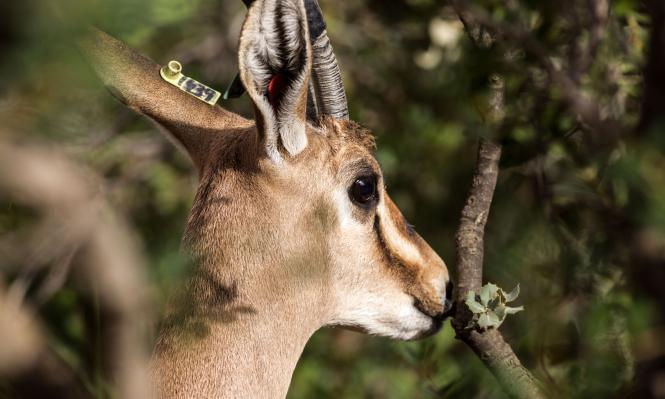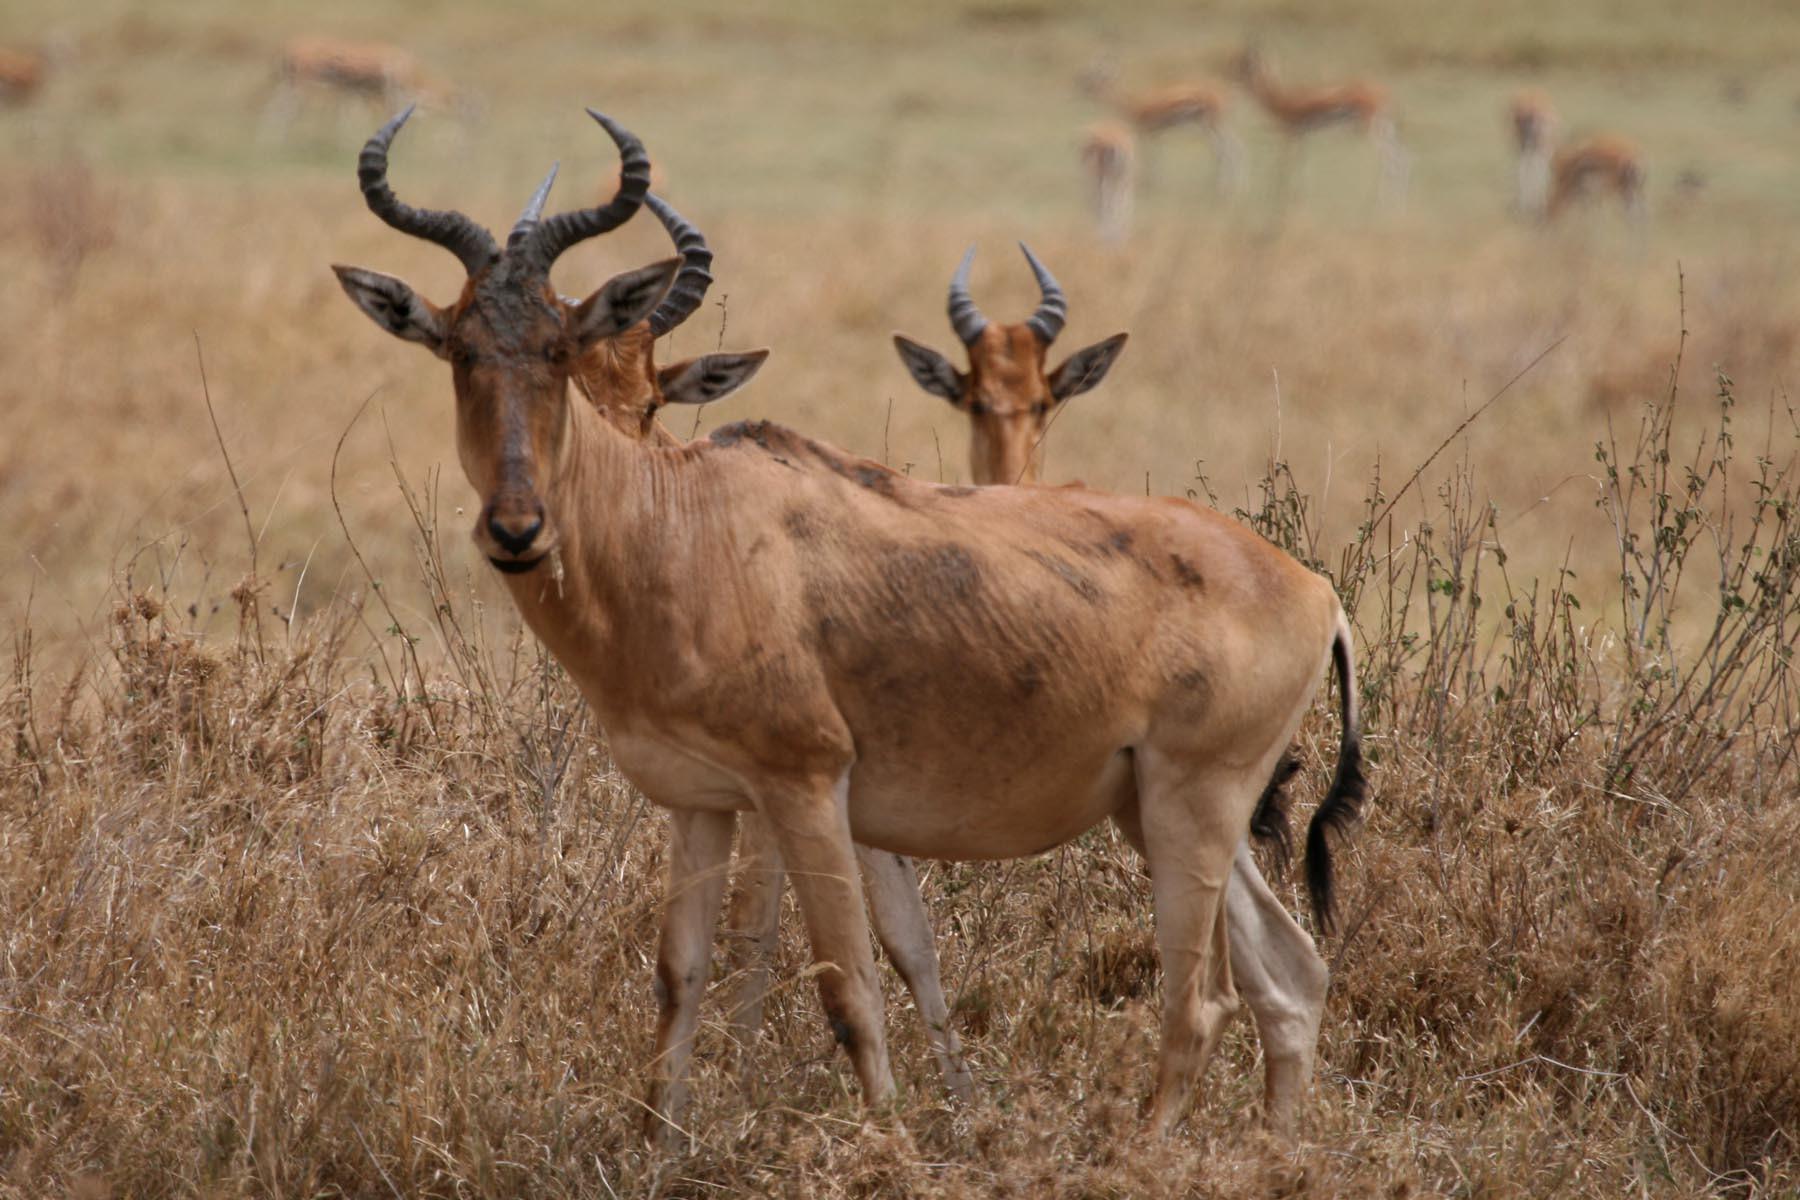The first image is the image on the left, the second image is the image on the right. For the images shown, is this caption "There are two animals in total." true? Answer yes or no. No. The first image is the image on the left, the second image is the image on the right. Given the left and right images, does the statement "One image includes at least twice the number of horned animals as the other image." hold true? Answer yes or no. No. 